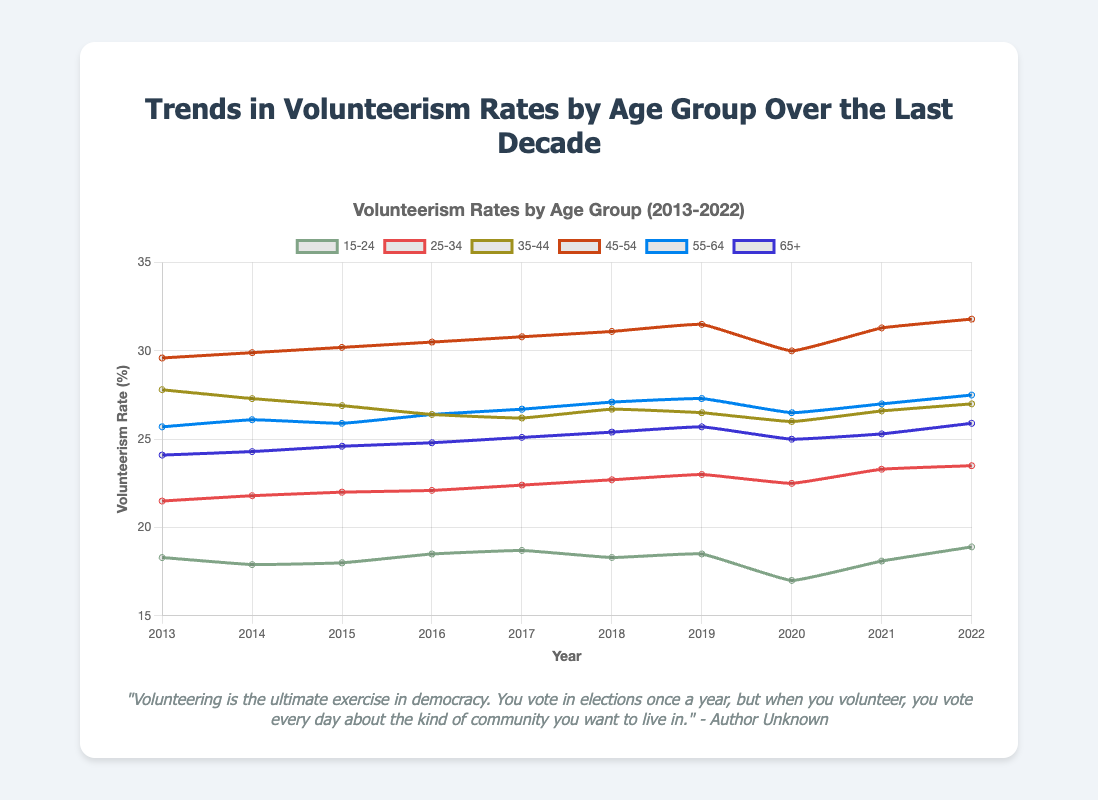Which age group has the highest volunteerism rate in 2022? To determine the highest volunteerism rate for 2022, inspect the values for each age group and identify the maximum. The rates are: 15-24 (18.9), 25-34 (23.5), 35-44 (27.0), 45-54 (31.8), 55-64 (27.5), and 65+ (25.9). The highest value is 31.8 for the 45-54 age group.
Answer: 45-54 What is the difference in the volunteerism rate between the 45-54 and 15-24 age groups in 2020? Refer to the 2020 data: 45-54 (30.0) and 15-24 (17.0). Subtract the 15-24 rate from the 45-54 rate: 30.0 - 17.0 = 13.0.
Answer: 13.0 Which age group shows the most consistent volunteerism rate from 2013 to 2022? Examine the data for each age group across the years and identify the one with the least variation. By assessing the fluctuations visually, the 65+ age group appears most consistent, with minor variations ranging from 24.1 to 25.9.
Answer: 65+ Has the volunteerism rate for the 25-34 age group increased or decreased from 2013 to 2022? Compare the rate in 2013 (21.5) to that in 2022 (23.5). The value increased from 21.5 to 23.5.
Answer: Increased What is the average volunteerism rate for the 35-44 age group across the decade? Add the rates from 2013 to 2022 and divide by the number of years: (27.8 + 27.3 + 26.9 + 26.4 + 26.2 + 26.7 + 26.5 + 26.0 + 26.6 + 27.0) / 10 = 26.74.
Answer: 26.74 Between which consecutive years did the volunteerism rate for the 55-64 age group increase the most? Compare the differences year-over-year for 55-64: the largest increase is between 2017 (26.7) and 2018 (27.1), which equals 0.4.
Answer: 2017 to 2018 What is the overall trend in volunteerism rates for the 15-24 age group from 2013 to 2022? Observe the line for the 15-24 age group, noting the general movement from the start to the end year. The trend shows minor fluctuations with a general slight increase: starting at 18.3 in 2013 and ending at 18.9 in 2022.
Answer: Slightly increasing By how much did the volunteerism rate for the 65+ age group change from 2014 to 2020? Calculate the difference between the rate in 2014 (24.3) and 2020 (25.0). Change = 25.0 - 24.3 = 0.7.
Answer: 0.7 Which age group experienced the largest decrease in volunteerism rate during the 2020 pandemic year? Examine 2020 data relative to 2019 for all age groups: 15-24 (1.5), 25-34 (0.5), 35-44 (0.5), 45-54 (1.5), 55-64 (0.8), and 65+ (0.7). The 15-24 and 45-54 groups both decreased by 1.5.
Answer: 15-24 and 45-54 